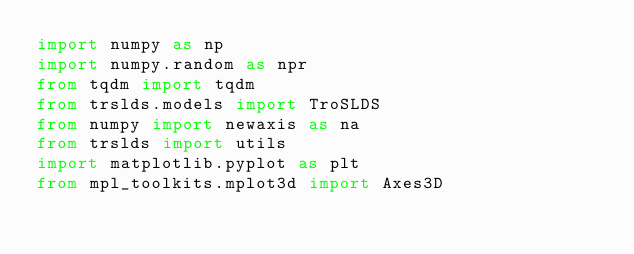Convert code to text. <code><loc_0><loc_0><loc_500><loc_500><_Python_>import numpy as np
import numpy.random as npr
from tqdm import tqdm
from trslds.models import TroSLDS
from numpy import newaxis as na
from trslds import utils
import matplotlib.pyplot as plt
from mpl_toolkits.mplot3d import Axes3D</code> 